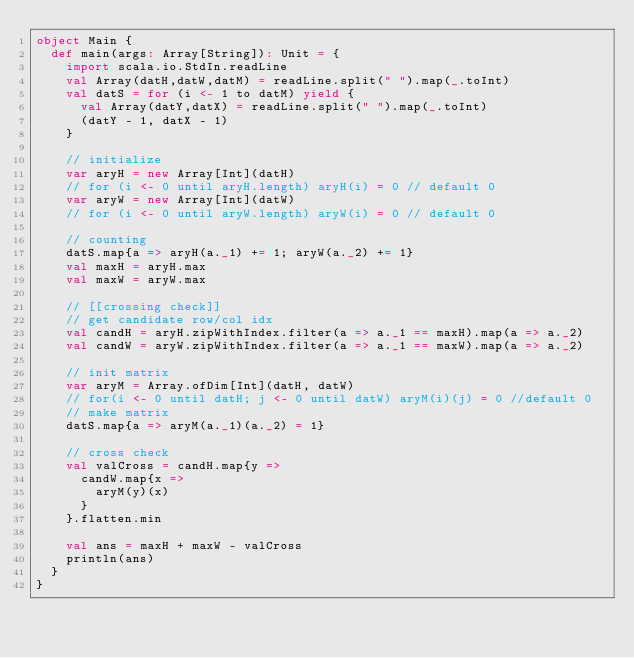Convert code to text. <code><loc_0><loc_0><loc_500><loc_500><_Scala_>object Main {
  def main(args: Array[String]): Unit = {
    import scala.io.StdIn.readLine
    val Array(datH,datW,datM) = readLine.split(" ").map(_.toInt)
    val datS = for (i <- 1 to datM) yield {
      val Array(datY,datX) = readLine.split(" ").map(_.toInt)
      (datY - 1, datX - 1)
    }

    // initialize
    var aryH = new Array[Int](datH)
    // for (i <- 0 until aryH.length) aryH(i) = 0 // default 0
    var aryW = new Array[Int](datW)
    // for (i <- 0 until aryW.length) aryW(i) = 0 // default 0

    // counting
    datS.map{a => aryH(a._1) += 1; aryW(a._2) += 1}
    val maxH = aryH.max
    val maxW = aryW.max

    // [[crossing check]]
    // get candidate row/col idx
    val candH = aryH.zipWithIndex.filter(a => a._1 == maxH).map(a => a._2)
    val candW = aryW.zipWithIndex.filter(a => a._1 == maxW).map(a => a._2)

    // init matrix
    var aryM = Array.ofDim[Int](datH, datW)
    // for(i <- 0 until datH; j <- 0 until datW) aryM(i)(j) = 0 //default 0
    // make matrix
    datS.map{a => aryM(a._1)(a._2) = 1}

    // cross check
    val valCross = candH.map{y =>
      candW.map{x =>
        aryM(y)(x)
      }
    }.flatten.min

    val ans = maxH + maxW - valCross
    println(ans)
  }
}
</code> 